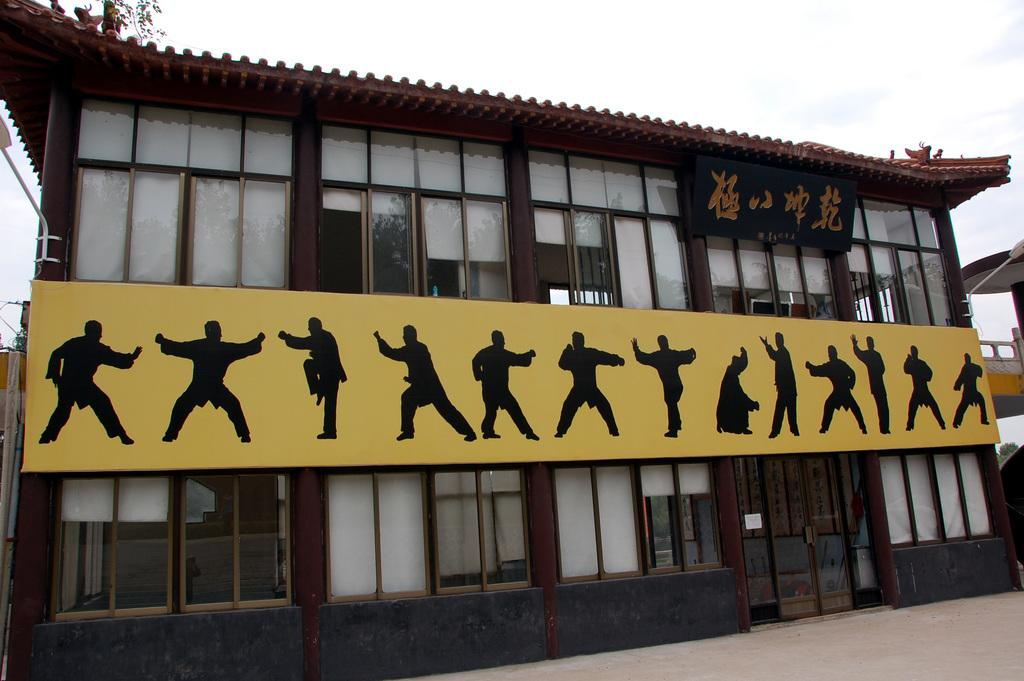What type of structure is present in the image? There is a building in the image. What can be seen on the boards in the image? The boards have something written on them. What is visible in the background of the image? The sky is visible in the image. What type of objects are present in the image? There are objects in the image. What is written on the blackboard? Something is written on a blackboard. What is depicted on the yellow board? On a yellow board, there are people in different positions. What type of floor is visible in the image? There is no floor visible in the image; it only shows a building, boards, and the sky. How does the knot affect the people on the yellow board? There is no knot present in the image, and therefore it cannot affect the people depicted on the yellow board. 